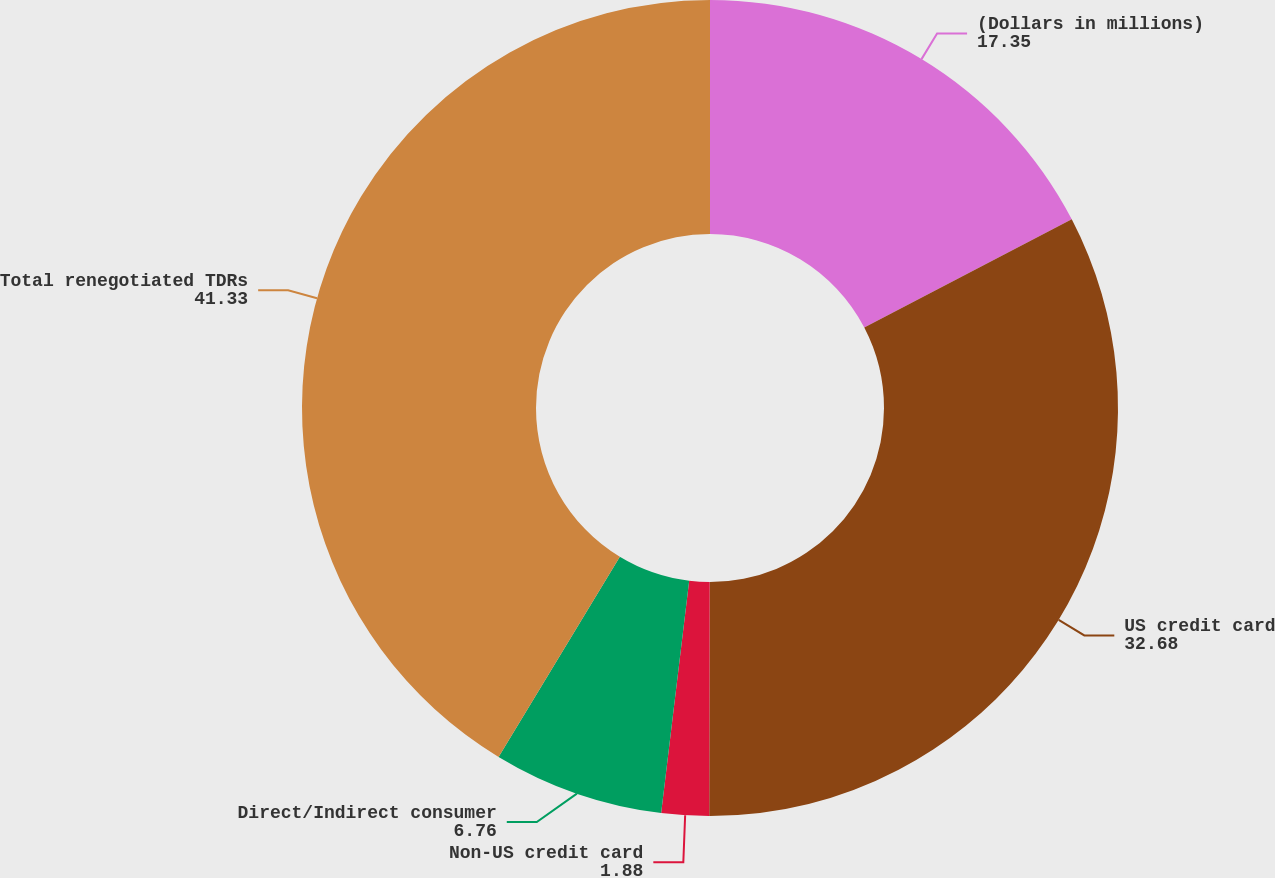Convert chart to OTSL. <chart><loc_0><loc_0><loc_500><loc_500><pie_chart><fcel>(Dollars in millions)<fcel>US credit card<fcel>Non-US credit card<fcel>Direct/Indirect consumer<fcel>Total renegotiated TDRs<nl><fcel>17.35%<fcel>32.68%<fcel>1.88%<fcel>6.76%<fcel>41.33%<nl></chart> 